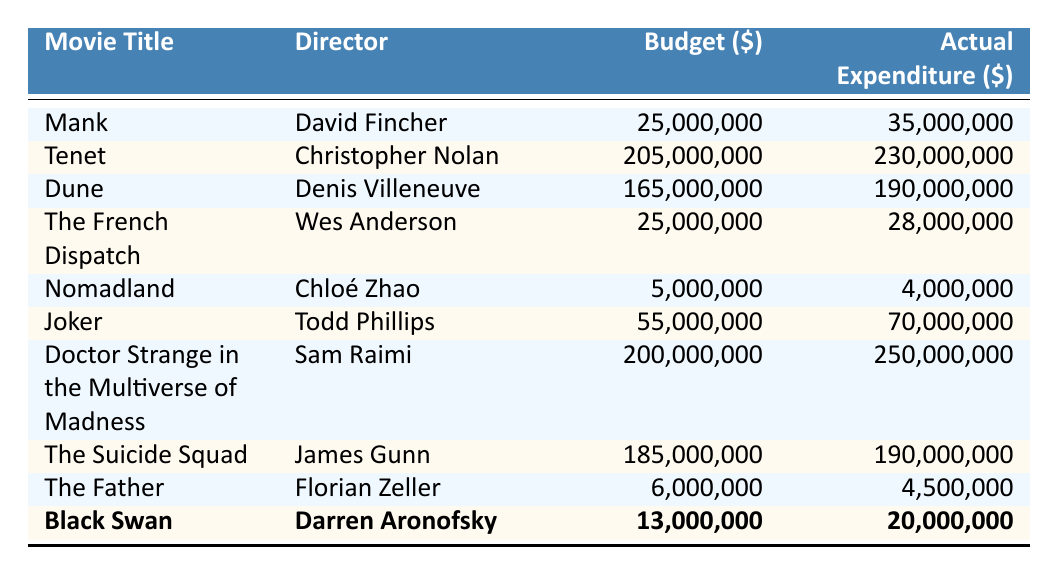What is the budget for "Joker"? The budget for "Joker" can be found in the table under the Budget column for that specific movie. It states 55,000,000.
Answer: 55,000,000 Which movie had the highest actual expenditure? "Doctor Strange in the Multiverse of Madness" has the highest actual expenditure of 250,000,000, which can be identified by comparing all the values in the Actual Expenditure column.
Answer: Doctor Strange in the Multiverse of Madness What is the difference between the budget and actual expenditure for "Dune"? The budget for "Dune" is 165,000,000 and the actual expenditure is 190,000,000. To find the difference, subtract the budget from the actual expenditure: 190,000,000 - 165,000,000 = 25,000,000.
Answer: 25,000,000 Is the actual expenditure for "The French Dispatch" less than its budget? The actual expenditure for "The French Dispatch" is 28,000,000, while the budget is 25,000,000. Since 28,000,000 is greater than 25,000,000, the answer is no.
Answer: No What is the average budget for the movies directed by Darren Aronofsky in the table? The only movie directed by Darren Aronofsky in the table is "Black Swan," which has a budget of 13,000,000. Since there's only one movie, the average is simply the budget itself: 13,000,000.
Answer: 13,000,000 What percentage over budget did "Mank" go? "Mank" had a budget of 25,000,000 and an actual expenditure of 35,000,000. To find the percentage over budget, calculate the difference (35,000,000 - 25,000,000 = 10,000,000), then divide this by the budget (10,000,000 / 25,000,000) and multiply by 100, resulting in 40%.
Answer: 40% Which director had a movie with actual expenditure lower than the budget? "Nomadland," directed by Chloé Zhao, has an actual expenditure of 4,000,000, which is less than its budget of 5,000,000. Therefore, Chloé Zhao qualifies as the director with a movie that met this criterion.
Answer: Chloé Zhao How many movies had an actual expenditure greater than 200 million? There are two movies that have an actual expenditure greater than 200 million: "Doctor Strange in the Multiverse of Madness" at 250,000,000 and "Tenet" at 230,000,000. Counting these gives us a total of 2 movies.
Answer: 2 What is the combined budget of "The Father" and "Nomadland"? "The Father" has a budget of 6,000,000 and "Nomadland" has a budget of 5,000,000. To find the combined budget, add these two amounts: 6,000,000 + 5,000,000 = 11,000,000.
Answer: 11,000,000 